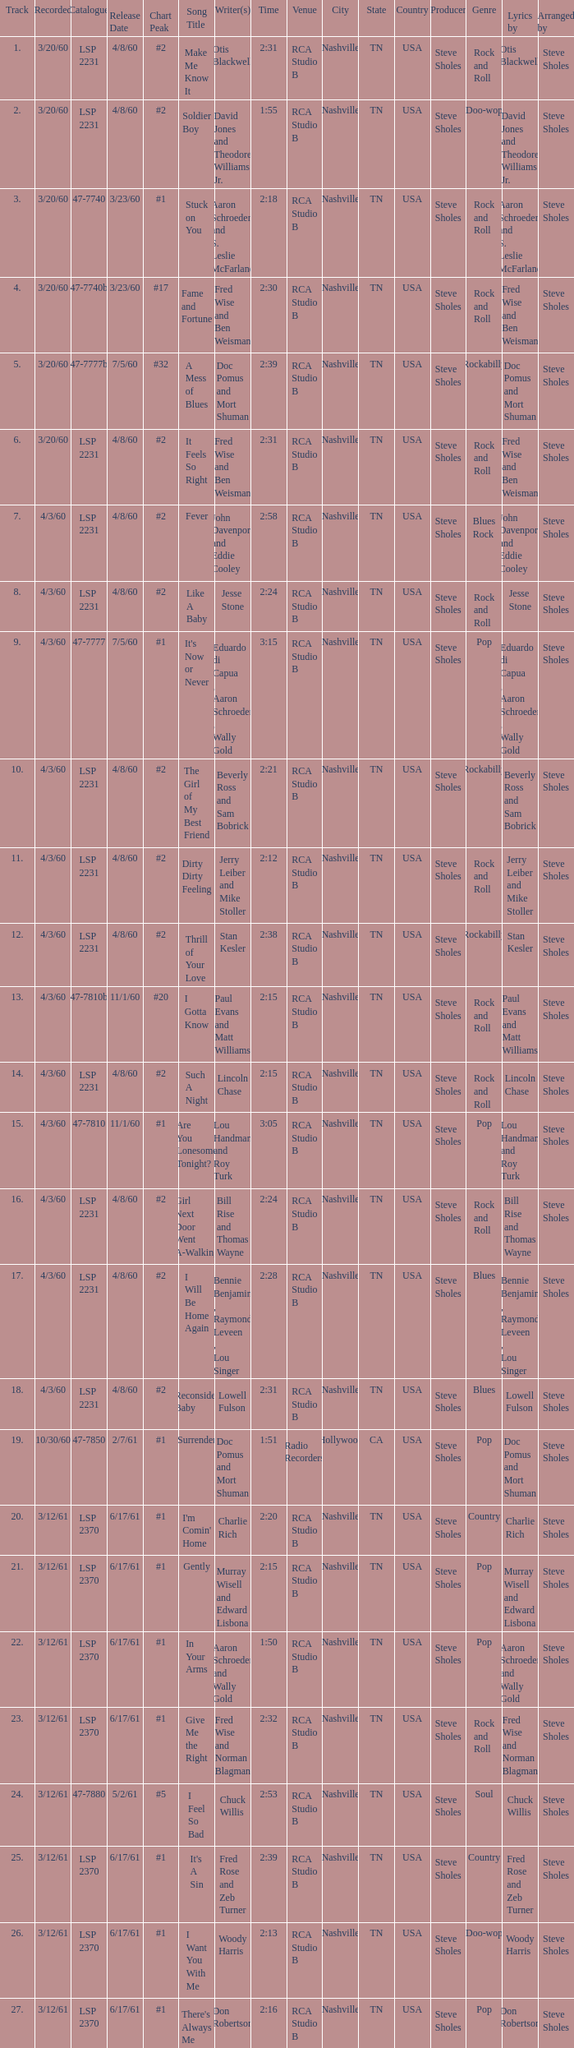What catalogue is the song It's Now or Never? 47-7777. 